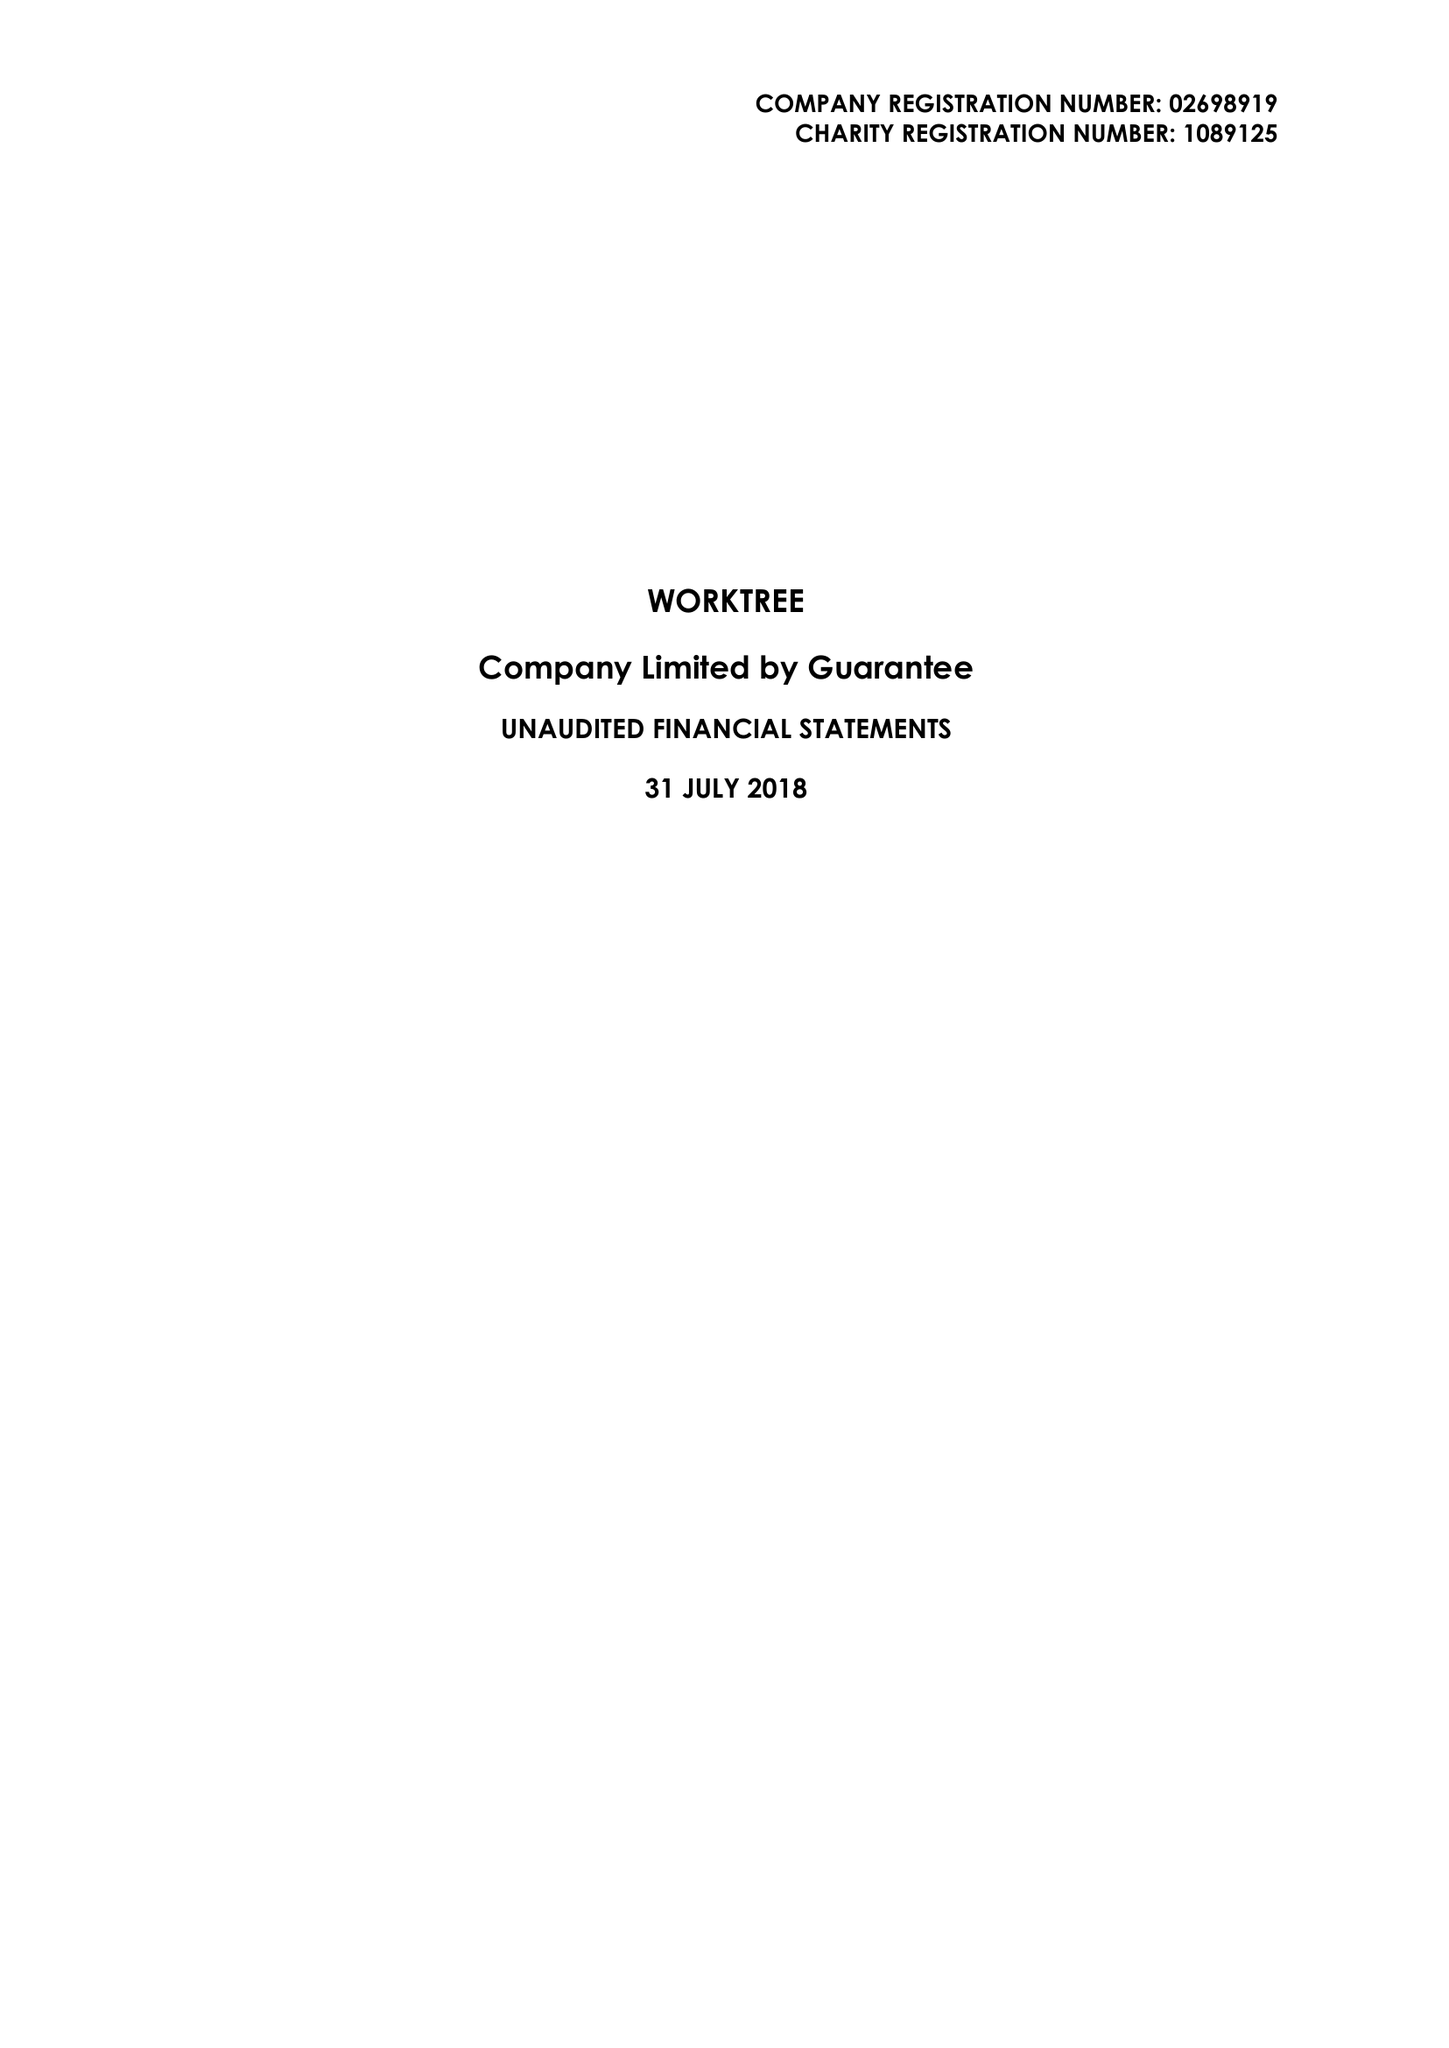What is the value for the charity_number?
Answer the question using a single word or phrase. 1089125 